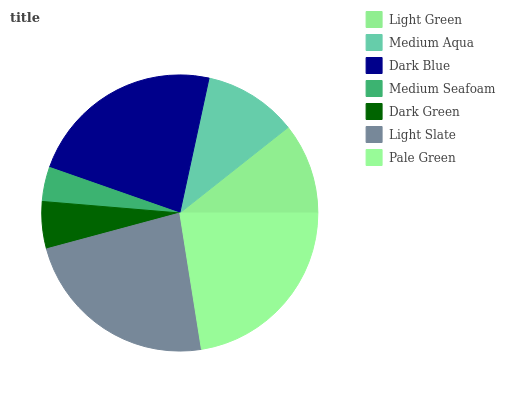Is Medium Seafoam the minimum?
Answer yes or no. Yes. Is Light Slate the maximum?
Answer yes or no. Yes. Is Medium Aqua the minimum?
Answer yes or no. No. Is Medium Aqua the maximum?
Answer yes or no. No. Is Medium Aqua greater than Light Green?
Answer yes or no. Yes. Is Light Green less than Medium Aqua?
Answer yes or no. Yes. Is Light Green greater than Medium Aqua?
Answer yes or no. No. Is Medium Aqua less than Light Green?
Answer yes or no. No. Is Medium Aqua the high median?
Answer yes or no. Yes. Is Medium Aqua the low median?
Answer yes or no. Yes. Is Light Slate the high median?
Answer yes or no. No. Is Dark Blue the low median?
Answer yes or no. No. 